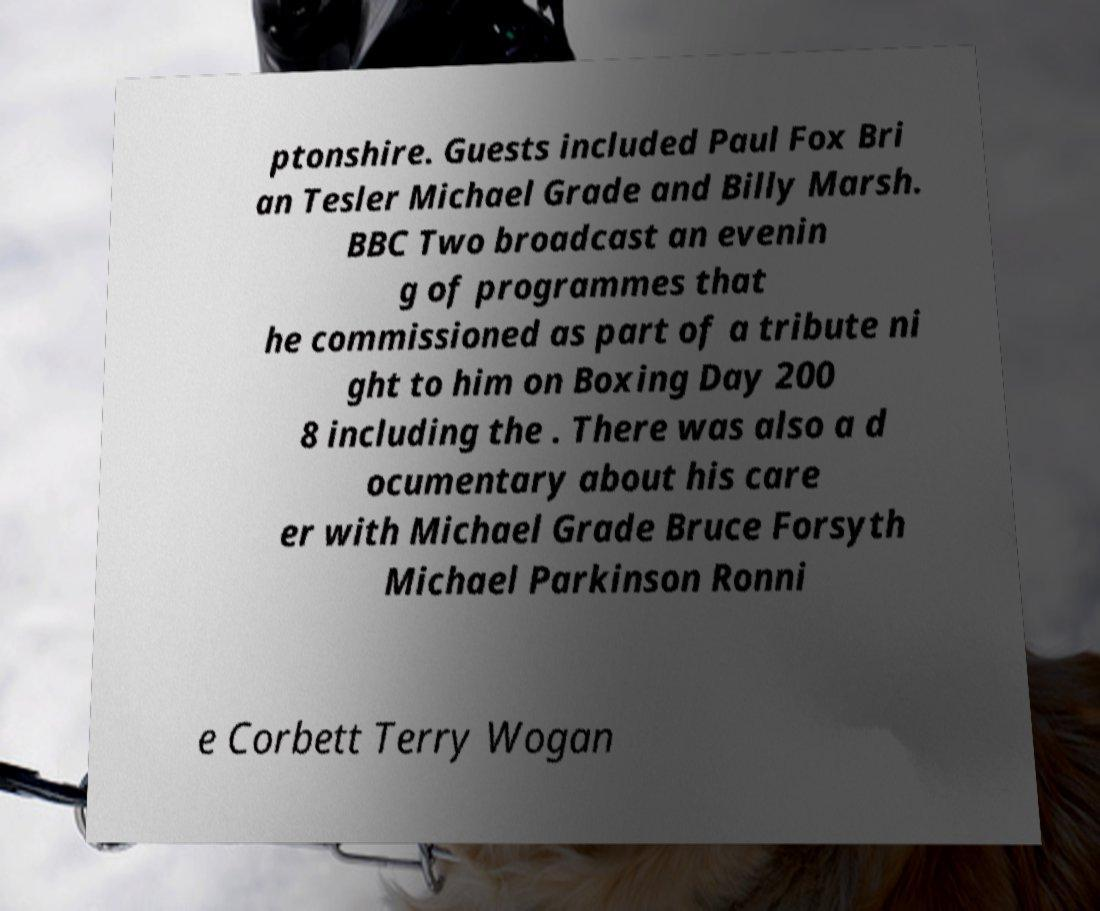Please identify and transcribe the text found in this image. ptonshire. Guests included Paul Fox Bri an Tesler Michael Grade and Billy Marsh. BBC Two broadcast an evenin g of programmes that he commissioned as part of a tribute ni ght to him on Boxing Day 200 8 including the . There was also a d ocumentary about his care er with Michael Grade Bruce Forsyth Michael Parkinson Ronni e Corbett Terry Wogan 